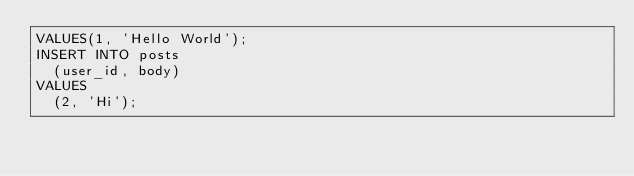<code> <loc_0><loc_0><loc_500><loc_500><_SQL_>VALUES(1, 'Hello World');
INSERT INTO posts
  (user_id, body)
VALUES
  (2, 'Hi');</code> 